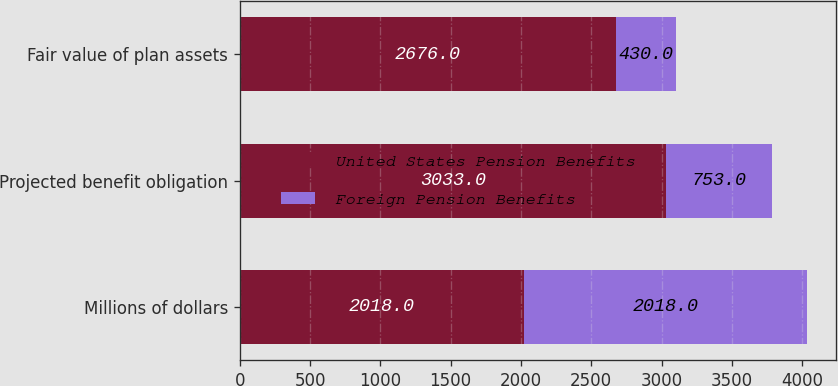Convert chart to OTSL. <chart><loc_0><loc_0><loc_500><loc_500><stacked_bar_chart><ecel><fcel>Millions of dollars<fcel>Projected benefit obligation<fcel>Fair value of plan assets<nl><fcel>United States Pension Benefits<fcel>2018<fcel>3033<fcel>2676<nl><fcel>Foreign Pension Benefits<fcel>2018<fcel>753<fcel>430<nl></chart> 